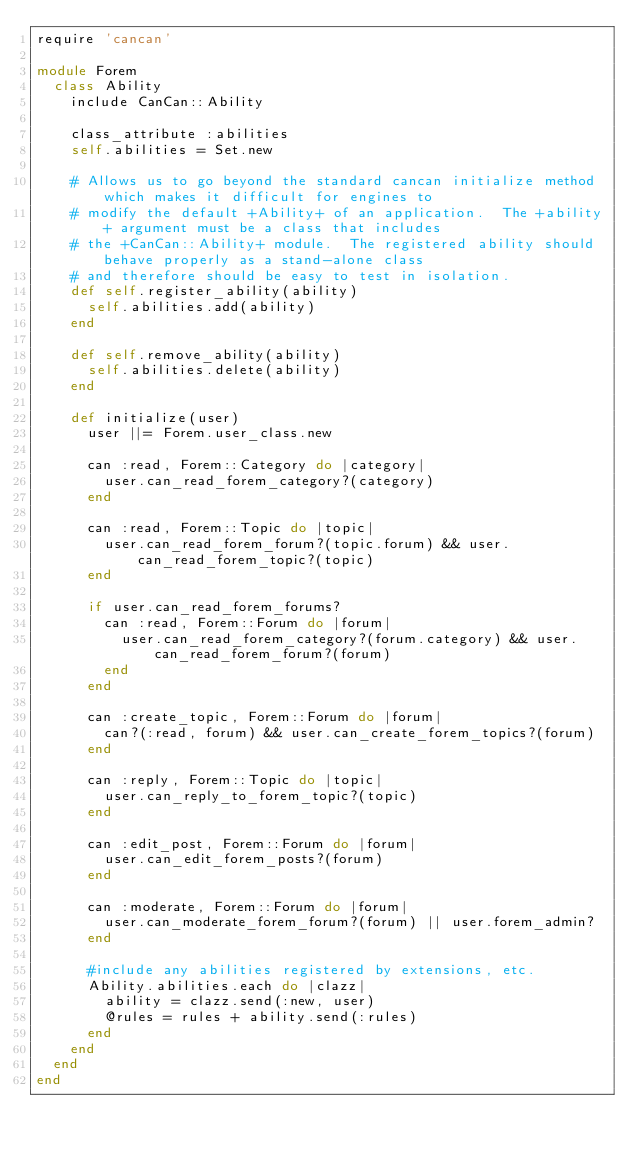Convert code to text. <code><loc_0><loc_0><loc_500><loc_500><_Ruby_>require 'cancan'

module Forem
  class Ability
    include CanCan::Ability

    class_attribute :abilities
    self.abilities = Set.new

    # Allows us to go beyond the standard cancan initialize method which makes it difficult for engines to
    # modify the default +Ability+ of an application.  The +ability+ argument must be a class that includes
    # the +CanCan::Ability+ module.  The registered ability should behave properly as a stand-alone class
    # and therefore should be easy to test in isolation.
    def self.register_ability(ability)
      self.abilities.add(ability)
    end

    def self.remove_ability(ability)
      self.abilities.delete(ability)
    end

    def initialize(user)
      user ||= Forem.user_class.new

      can :read, Forem::Category do |category|
        user.can_read_forem_category?(category)
      end

      can :read, Forem::Topic do |topic|
        user.can_read_forem_forum?(topic.forum) && user.can_read_forem_topic?(topic)
      end

      if user.can_read_forem_forums?
        can :read, Forem::Forum do |forum|
          user.can_read_forem_category?(forum.category) && user.can_read_forem_forum?(forum)
        end
      end

      can :create_topic, Forem::Forum do |forum|
        can?(:read, forum) && user.can_create_forem_topics?(forum)
      end

      can :reply, Forem::Topic do |topic|
        user.can_reply_to_forem_topic?(topic)
      end

      can :edit_post, Forem::Forum do |forum|
        user.can_edit_forem_posts?(forum)
      end

      can :moderate, Forem::Forum do |forum|
        user.can_moderate_forem_forum?(forum) || user.forem_admin?
      end

      #include any abilities registered by extensions, etc.
      Ability.abilities.each do |clazz|
        ability = clazz.send(:new, user)
        @rules = rules + ability.send(:rules)
      end
    end
  end
end
</code> 